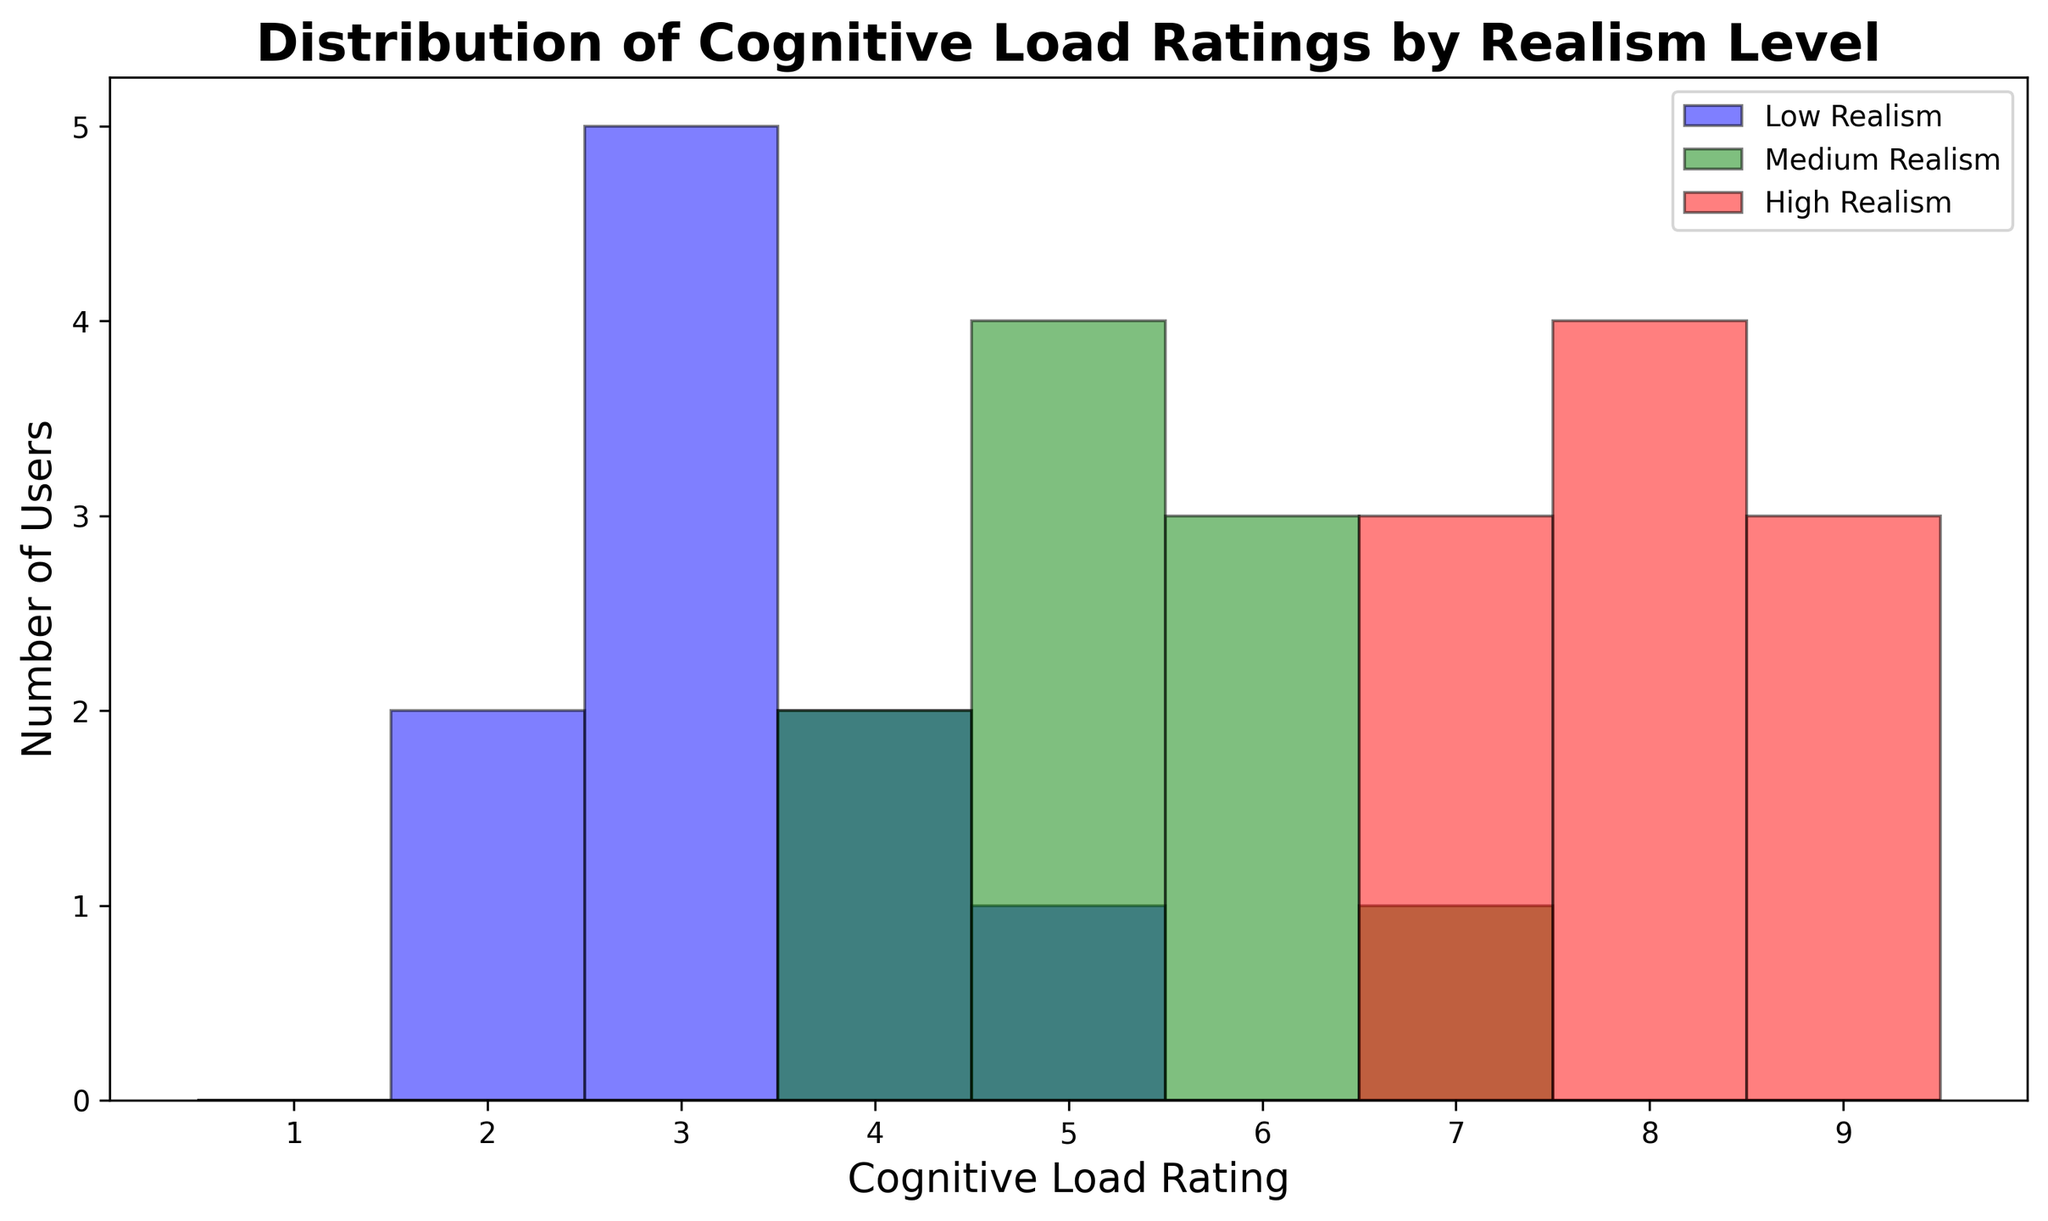What is the most common cognitive load rating for the high realism level? The histogram visually shows the frequency of each cognitive load rating for each realism level. For the high realism level, the bars corresponding to ratings 7, 8, and 9 are the tallest. However, the 8 rating appears to have slightly more users than the others.
Answer: 8 Which realism level has the highest average cognitive load rating? To determine the average cognitive load rating for each realism level, look at the histograms for low, medium, and high realism. The high realism level has most of its ratings in the higher values (7-9), while medium realism has many ratings around 5-6, and low realism is mostly around 3-4. Thus, the high realism level has the highest average cognitive load rating.
Answer: High Are there more users with a cognitive load rating of 5 in medium realism than in low realism? Check the height of the bars corresponding to a cognitive load rating of 5 for both medium and low realism. The medium realism bar (green) for rating 5 is taller than the low realism bar (blue) for the same rating, indicating more users in the medium realism level.
Answer: Yes What is the difference between the number of users with the highest cognitive load rating in high realism and the lowest cognitive load rating in low realism? The highest cognitive load rating in high realism is 9, and the histogram indicates that there are 4 users with this rating. The lowest cognitive load rating in low realism is 2, and the histogram shows 2 users with this rating. The difference is
Answer: 2 Which cognitive load rating has the widest spread (range) among the three realism levels? The range of cognitive load ratings for each level can be determined by the horizontal spread of the histograms. Low realism ranges from 2 to 5, medium realism ranges from 4 to 7, and high realism ranges from 7 to 9. The medium realism, therefore, has the widest range from 4 to 7, spanning 3 units.
Answer: Medium Does the high realism level have any cognitive load ratings that are not observed in the low realism level? By comparing the cognitive load ratings present in the histograms of both high and low realism levels, the high realism level has ratings of 7, 8, and 9, whereas the low realism level has ratings from 2 to 5. Therefore, the ratings 7, 8, and 9 are not observed in the low realism level.
Answer: Yes How many more users rated their cognitive load as 4 in medium realism compared to high realism? By looking at the bars corresponding to a rating of 4 for medium and high realism: the medium realism level has 2 users while the high realism level has no users (bar height is 0) for that rating. Thus, the difference is
Answer: 2 Is the cognitive load distribution more skewed towards the lower end or the higher end for low realism? Observing the low realism histogram (blue bars), there are more bars with higher frequencies on the lower rating values (2 and 3). This indicates that the distribution is skewed towards the lower end.
Answer: Lower end 